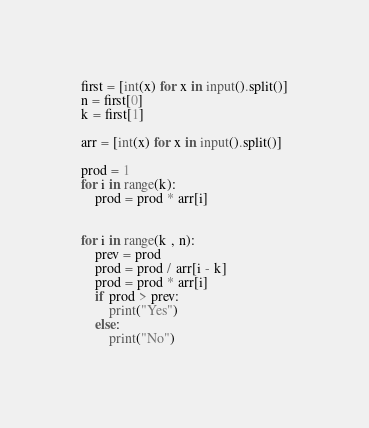<code> <loc_0><loc_0><loc_500><loc_500><_Python_>first = [int(x) for x in input().split()]
n = first[0]
k = first[1]

arr = [int(x) for x in input().split()]

prod = 1
for i in range(k):
	prod = prod * arr[i]


for i in range(k , n):
	prev = prod
	prod = prod / arr[i - k]
	prod = prod * arr[i]
	if prod > prev:
		print("Yes")
	else:
		print("No")

</code> 